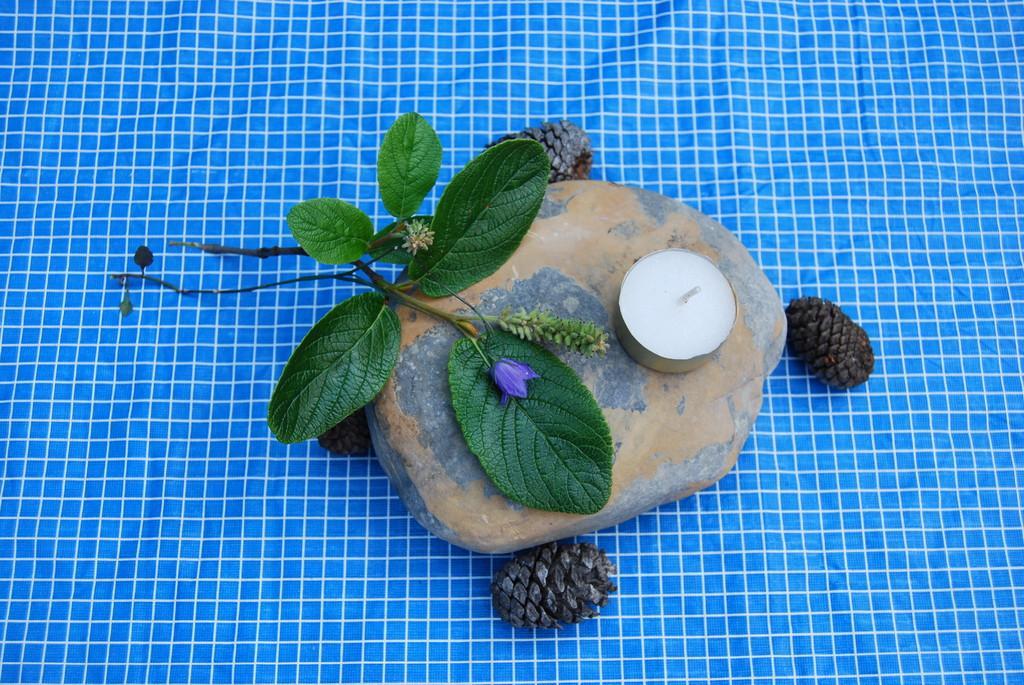In one or two sentences, can you explain what this image depicts? There is a blue and white check cloth. On that there is a stone, pine cones and a plant with leaves and flower. On the stone there is a candle. 